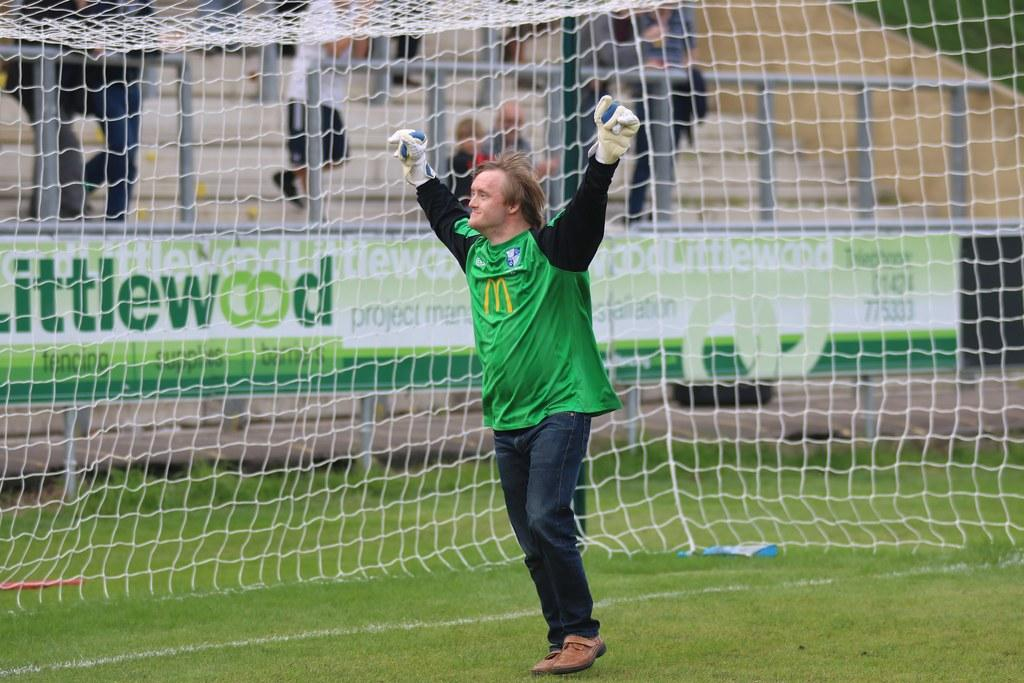<image>
Provide a brief description of the given image. the green banner behind the goal says Littlewood 